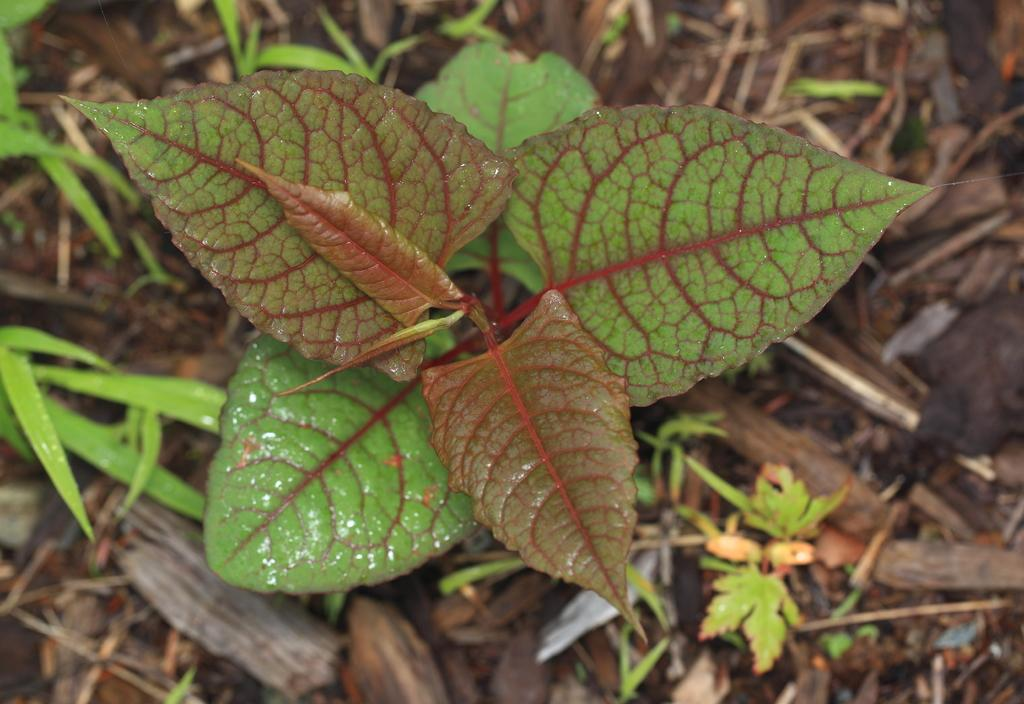What type of vegetation is present in the image? There is a plant and grass visible in the image. What material are the sticks on the ground made of? The sticks on the ground are made of wood. What type of flowers can be seen growing on the ice in the image? There is no ice or flowers present in the image; it features a plant, grass, and wooden sticks. 